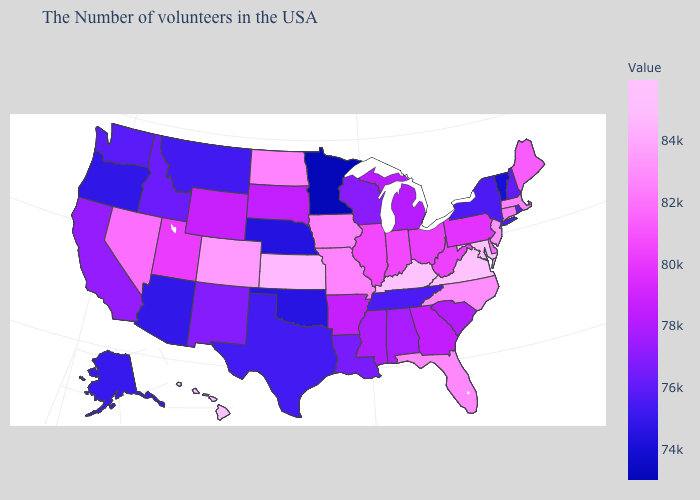Among the states that border Oklahoma , which have the highest value?
Keep it brief. Kansas. Among the states that border Nevada , which have the lowest value?
Answer briefly. Oregon. Which states have the highest value in the USA?
Write a very short answer. Virginia. Does Virginia have the highest value in the USA?
Be succinct. Yes. Does Arizona have a lower value than Minnesota?
Short answer required. No. 